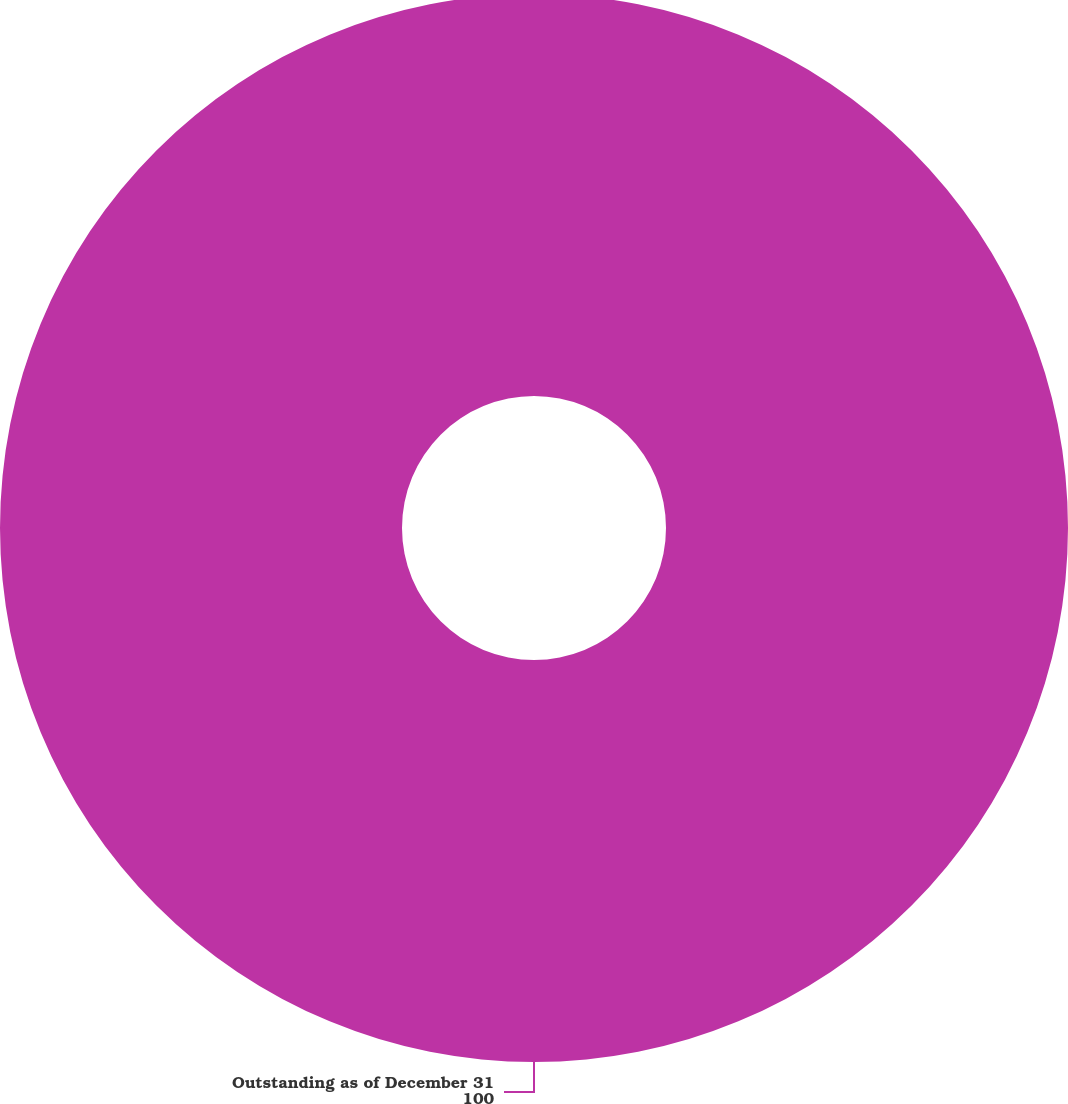<chart> <loc_0><loc_0><loc_500><loc_500><pie_chart><fcel>Outstanding as of December 31<nl><fcel>100.0%<nl></chart> 